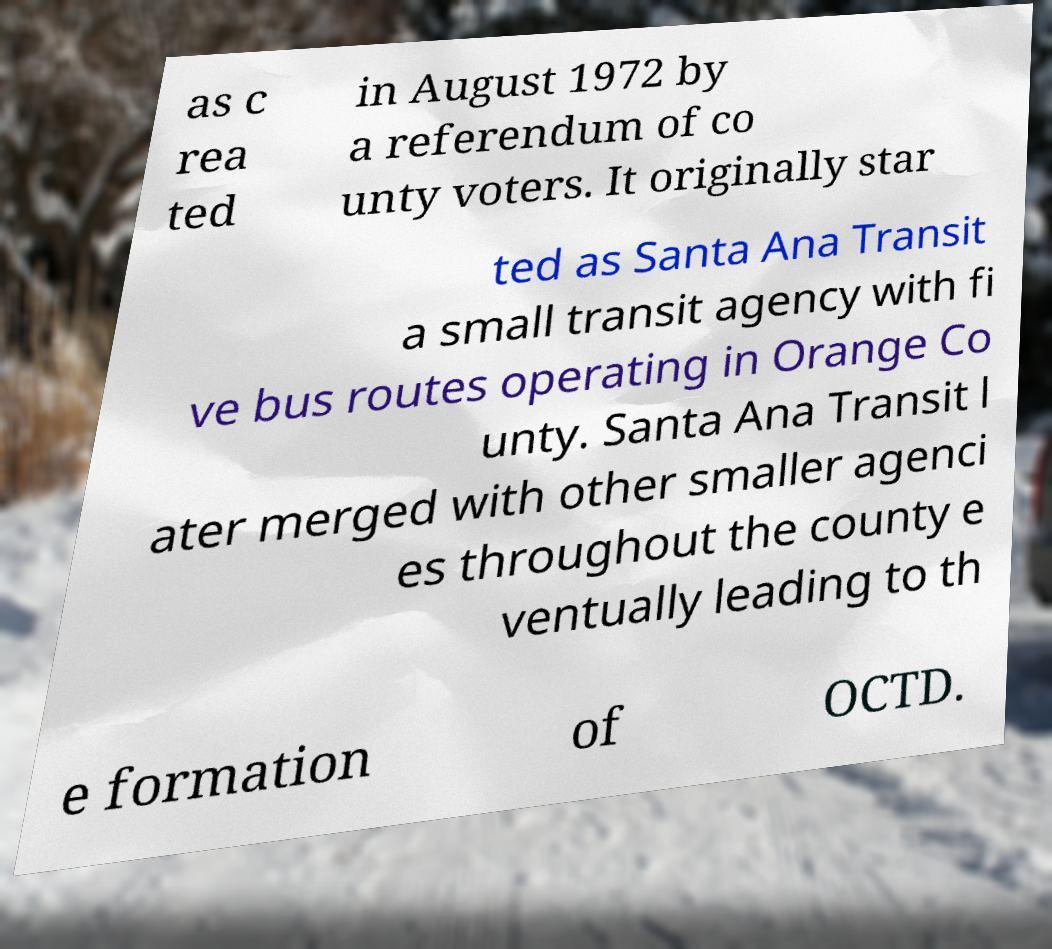Can you accurately transcribe the text from the provided image for me? as c rea ted in August 1972 by a referendum of co unty voters. It originally star ted as Santa Ana Transit a small transit agency with fi ve bus routes operating in Orange Co unty. Santa Ana Transit l ater merged with other smaller agenci es throughout the county e ventually leading to th e formation of OCTD. 